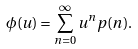<formula> <loc_0><loc_0><loc_500><loc_500>\phi ( u ) = \sum _ { n = 0 } ^ { \infty } u ^ { n } p ( n ) .</formula> 